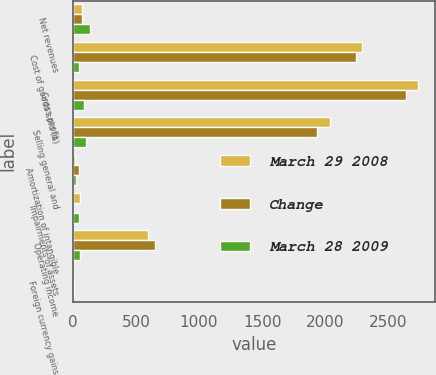<chart> <loc_0><loc_0><loc_500><loc_500><stacked_bar_chart><ecel><fcel>Net revenues<fcel>Cost of goods sold (a)<fcel>Gross profit<fcel>Selling general and<fcel>Amortization of intangible<fcel>Impairments of assets<fcel>Operating income<fcel>Foreign currency gains<nl><fcel>March 29 2008<fcel>75.25<fcel>2288.2<fcel>2730.7<fcel>2036<fcel>20.2<fcel>55.4<fcel>595.5<fcel>1.6<nl><fcel>Change<fcel>75.25<fcel>2242<fcel>2638.1<fcel>1932.5<fcel>47.2<fcel>5<fcel>653.4<fcel>6.4<nl><fcel>March 28 2009<fcel>138.8<fcel>46.2<fcel>92.6<fcel>103.5<fcel>27<fcel>50.4<fcel>57.9<fcel>8<nl></chart> 